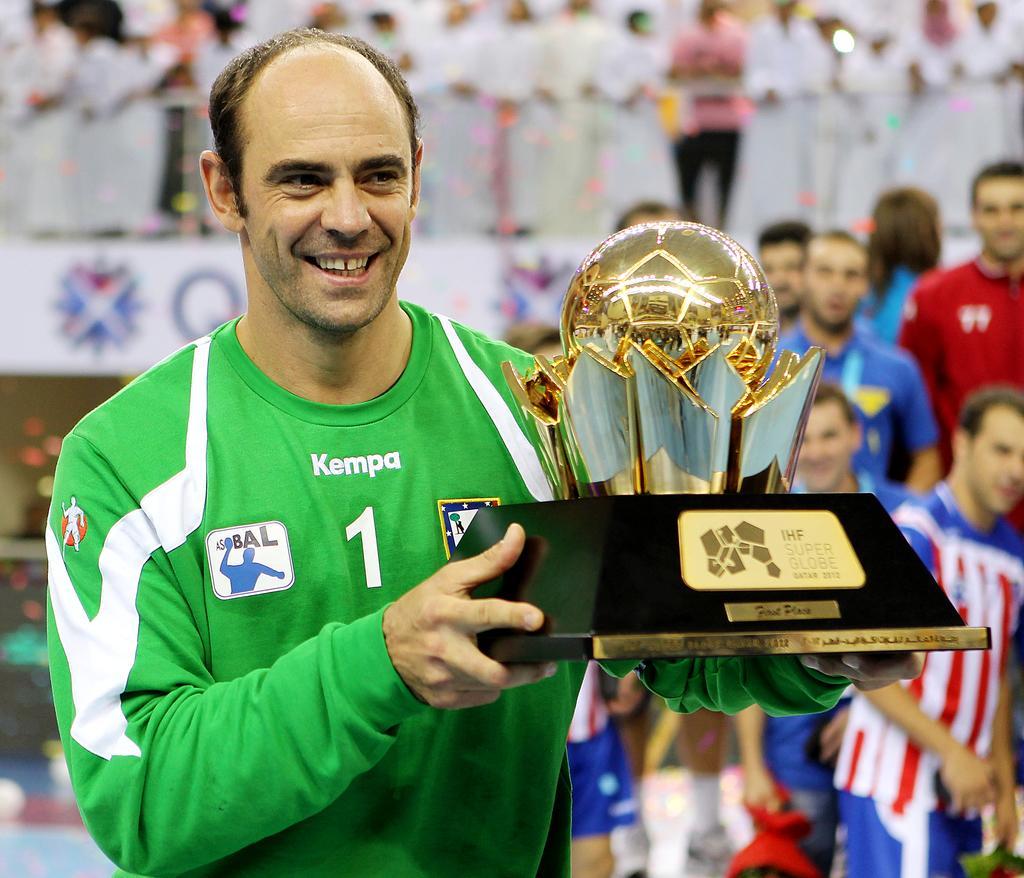Can you describe this image briefly? This picture shows few people standing and we see a man standing and holding a moment in his hand and we see smile on his face and he wore a green and white color t-shirt. 